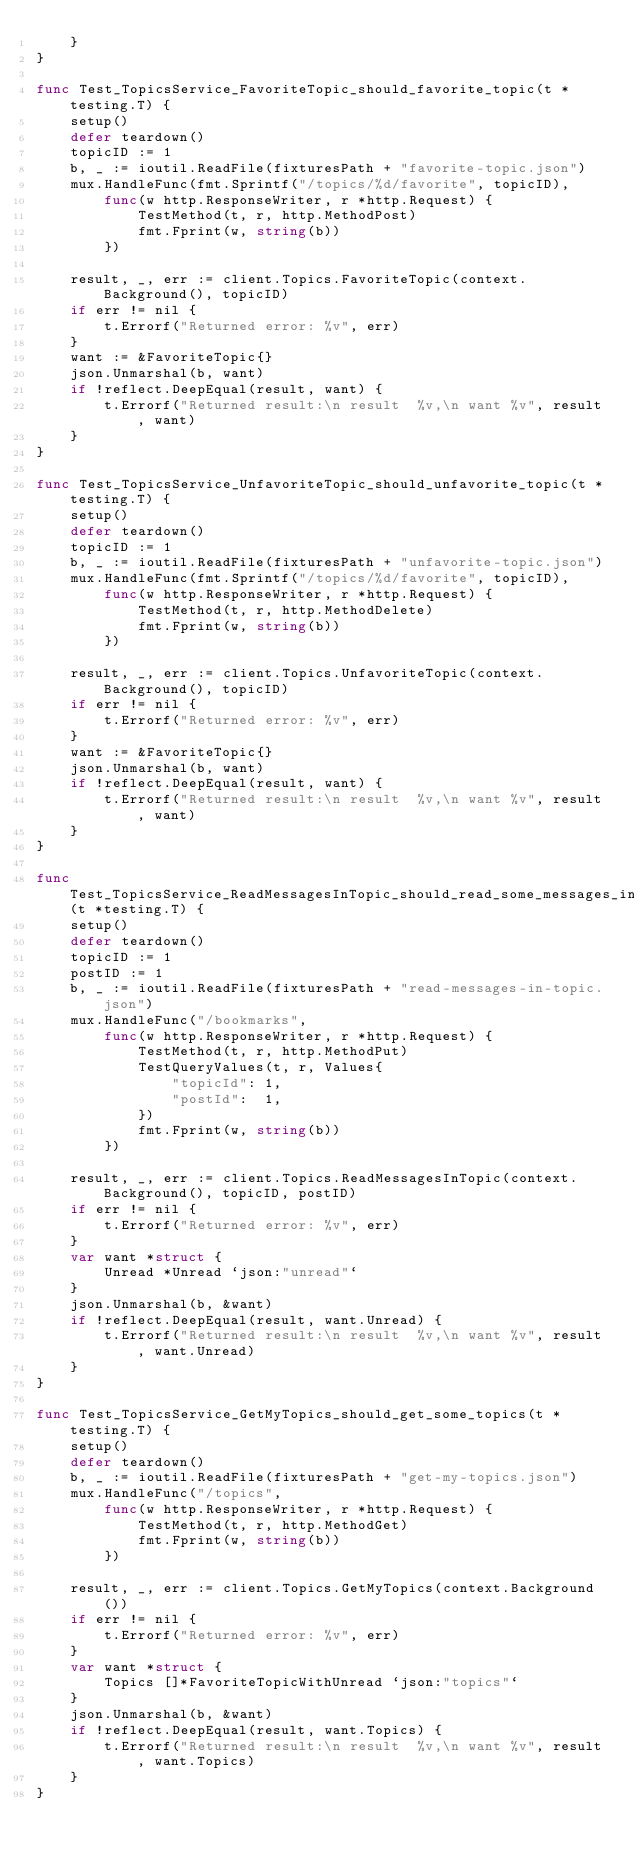Convert code to text. <code><loc_0><loc_0><loc_500><loc_500><_Go_>	}
}

func Test_TopicsService_FavoriteTopic_should_favorite_topic(t *testing.T) {
	setup()
	defer teardown()
	topicID := 1
	b, _ := ioutil.ReadFile(fixturesPath + "favorite-topic.json")
	mux.HandleFunc(fmt.Sprintf("/topics/%d/favorite", topicID),
		func(w http.ResponseWriter, r *http.Request) {
			TestMethod(t, r, http.MethodPost)
			fmt.Fprint(w, string(b))
		})

	result, _, err := client.Topics.FavoriteTopic(context.Background(), topicID)
	if err != nil {
		t.Errorf("Returned error: %v", err)
	}
	want := &FavoriteTopic{}
	json.Unmarshal(b, want)
	if !reflect.DeepEqual(result, want) {
		t.Errorf("Returned result:\n result  %v,\n want %v", result, want)
	}
}

func Test_TopicsService_UnfavoriteTopic_should_unfavorite_topic(t *testing.T) {
	setup()
	defer teardown()
	topicID := 1
	b, _ := ioutil.ReadFile(fixturesPath + "unfavorite-topic.json")
	mux.HandleFunc(fmt.Sprintf("/topics/%d/favorite", topicID),
		func(w http.ResponseWriter, r *http.Request) {
			TestMethod(t, r, http.MethodDelete)
			fmt.Fprint(w, string(b))
		})

	result, _, err := client.Topics.UnfavoriteTopic(context.Background(), topicID)
	if err != nil {
		t.Errorf("Returned error: %v", err)
	}
	want := &FavoriteTopic{}
	json.Unmarshal(b, want)
	if !reflect.DeepEqual(result, want) {
		t.Errorf("Returned result:\n result  %v,\n want %v", result, want)
	}
}

func Test_TopicsService_ReadMessagesInTopic_should_read_some_messages_in_topic(t *testing.T) {
	setup()
	defer teardown()
	topicID := 1
	postID := 1
	b, _ := ioutil.ReadFile(fixturesPath + "read-messages-in-topic.json")
	mux.HandleFunc("/bookmarks",
		func(w http.ResponseWriter, r *http.Request) {
			TestMethod(t, r, http.MethodPut)
			TestQueryValues(t, r, Values{
				"topicId": 1,
				"postId":  1,
			})
			fmt.Fprint(w, string(b))
		})

	result, _, err := client.Topics.ReadMessagesInTopic(context.Background(), topicID, postID)
	if err != nil {
		t.Errorf("Returned error: %v", err)
	}
	var want *struct {
		Unread *Unread `json:"unread"`
	}
	json.Unmarshal(b, &want)
	if !reflect.DeepEqual(result, want.Unread) {
		t.Errorf("Returned result:\n result  %v,\n want %v", result, want.Unread)
	}
}

func Test_TopicsService_GetMyTopics_should_get_some_topics(t *testing.T) {
	setup()
	defer teardown()
	b, _ := ioutil.ReadFile(fixturesPath + "get-my-topics.json")
	mux.HandleFunc("/topics",
		func(w http.ResponseWriter, r *http.Request) {
			TestMethod(t, r, http.MethodGet)
			fmt.Fprint(w, string(b))
		})

	result, _, err := client.Topics.GetMyTopics(context.Background())
	if err != nil {
		t.Errorf("Returned error: %v", err)
	}
	var want *struct {
		Topics []*FavoriteTopicWithUnread `json:"topics"`
	}
	json.Unmarshal(b, &want)
	if !reflect.DeepEqual(result, want.Topics) {
		t.Errorf("Returned result:\n result  %v,\n want %v", result, want.Topics)
	}
}
</code> 